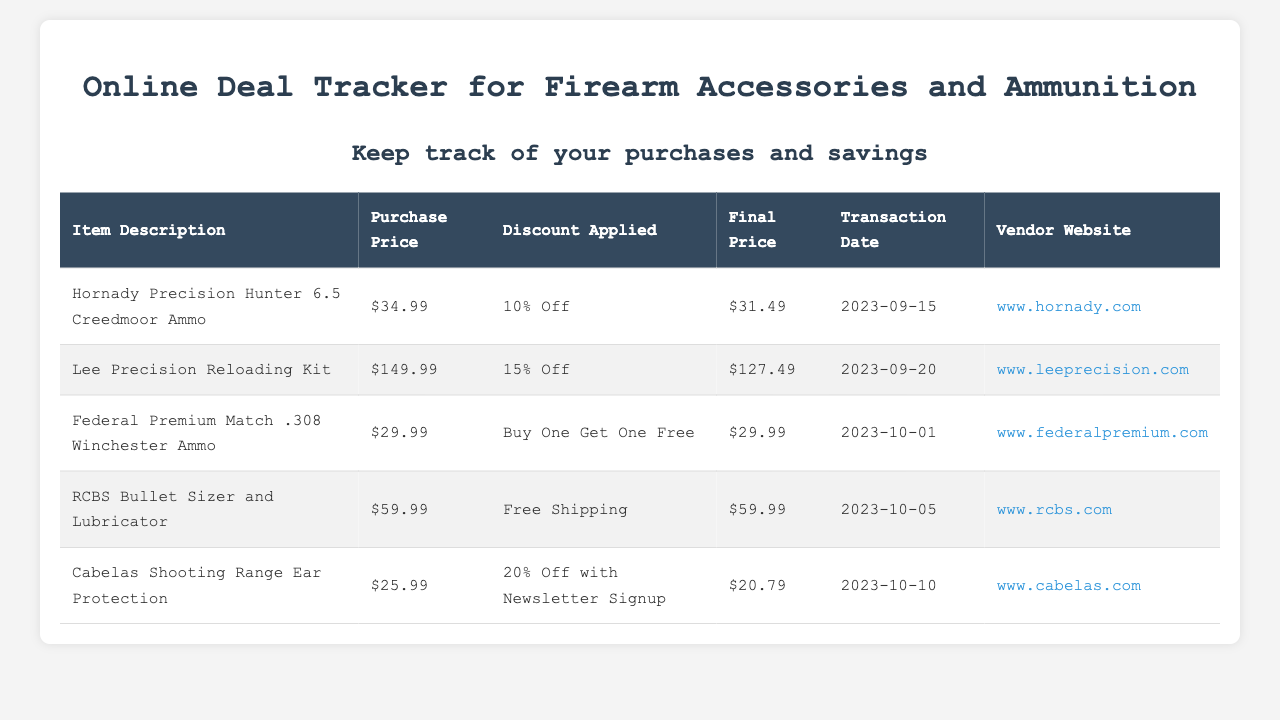What is the final price of Hornady Precision Hunter 6.5 Creedmoor Ammo? The final price is the amount after the discount is applied, which is $31.49.
Answer: $31.49 What is the discount applied on the Lee Precision Reloading Kit? The discount for this kit is noted as 15% Off.
Answer: 15% Off When was the transaction date for the Cabelas Shooting Range Ear Protection? The transaction date is listed as 2023-10-10.
Answer: 2023-10-10 How much did the Federal Premium Match .308 Winchester Ammo cost? The purchase price for this ammo is $29.99.
Answer: $29.99 Which vendor sold the RCBS Bullet Sizer and Lubricator? The vendor's name can be found with a link, which is www.rcbs.com.
Answer: www.rcbs.com What was the total number of items purchased in the document? Each row represents a different item, and there are a total of 5 items listed.
Answer: 5 What percentage discount did you get on the Cabelas Shooting Range Ear Protection? The discount for this item provided in the document is 20% Off with Newsletter Signup.
Answer: 20% Off Which item had the lowest final price recorded? The final prices indicate that Cabelas Shooting Range Ear Protection is the lowest at $20.79.
Answer: $20.79 What type of discount was offered for the Federal Premium Match .308 Winchester Ammo? The item received a discount classified as Buy One Get One Free.
Answer: Buy One Get One Free 